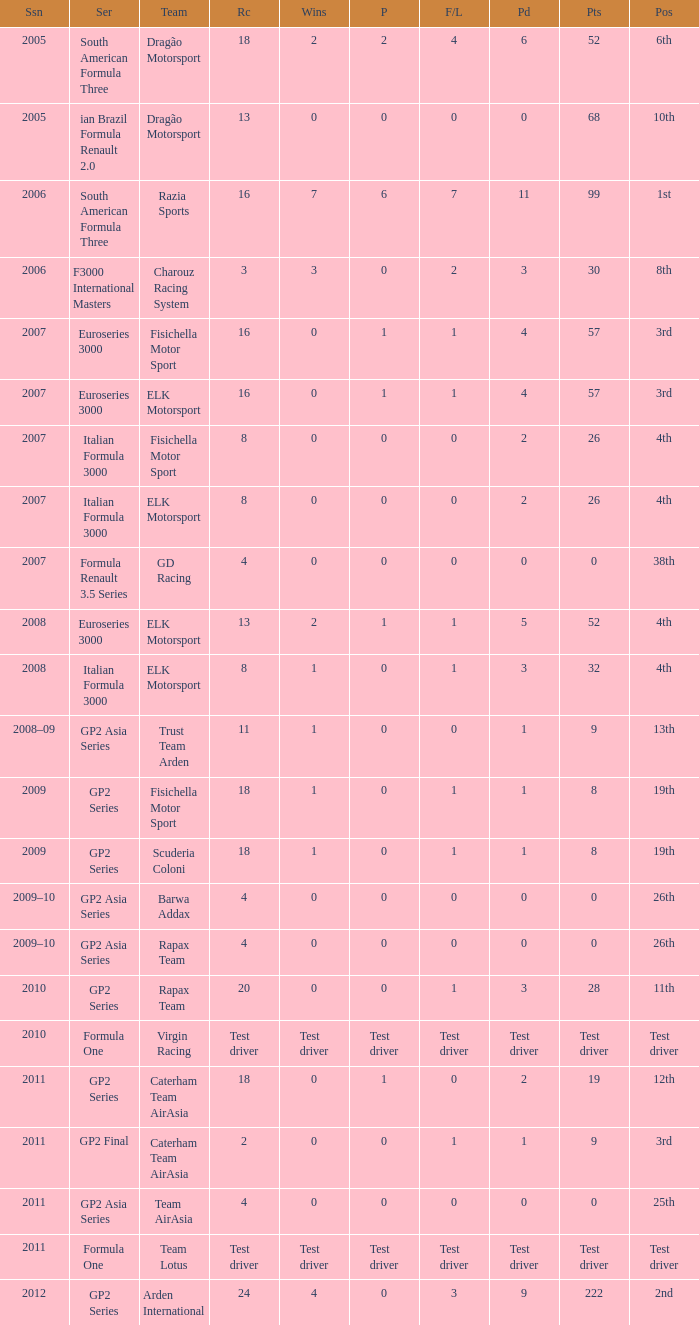How many races did he do in the year he had 8 points? 18, 18. 